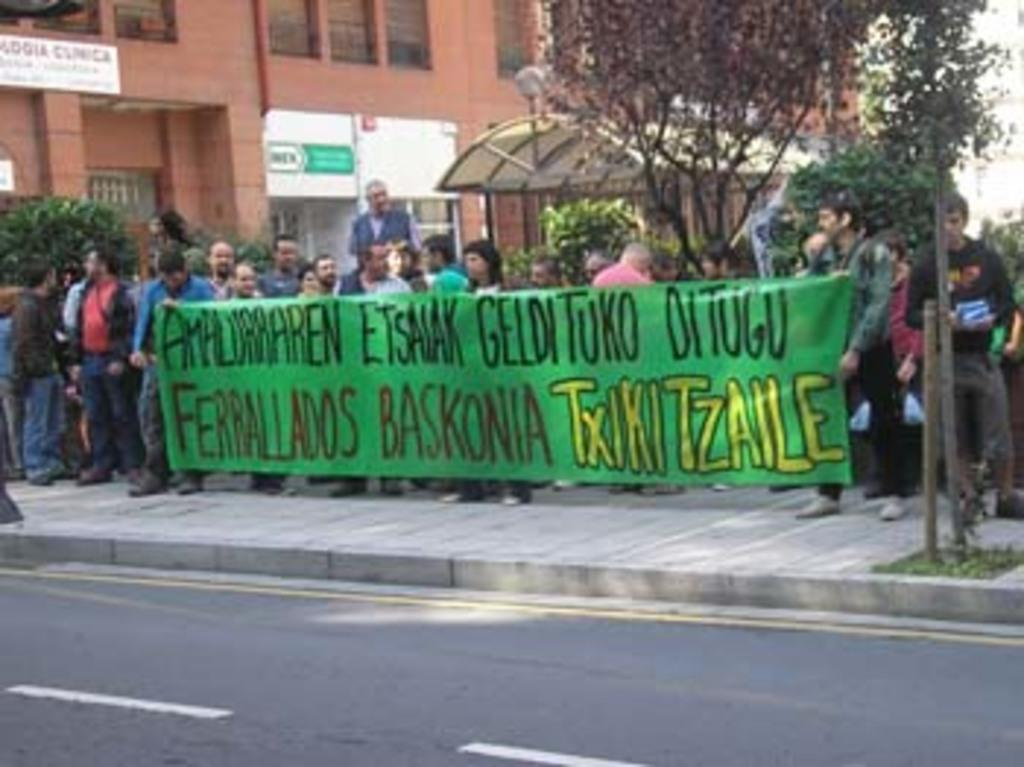What is the main feature of the image? There is a road in the image. What else can be seen in the image besides the road? There is a banner, people, plants, trees, boards, and buildings in the image. Can you describe the banner in the image? The banner is a sign or advertisement that is visible in the image. What type of vegetation is present in the image? There are plants and trees in the image. What type of tank can be seen in the image? There is no tank present in the image. What part of the human body is visible in the image? There is no flesh or human body part visible in the image. 